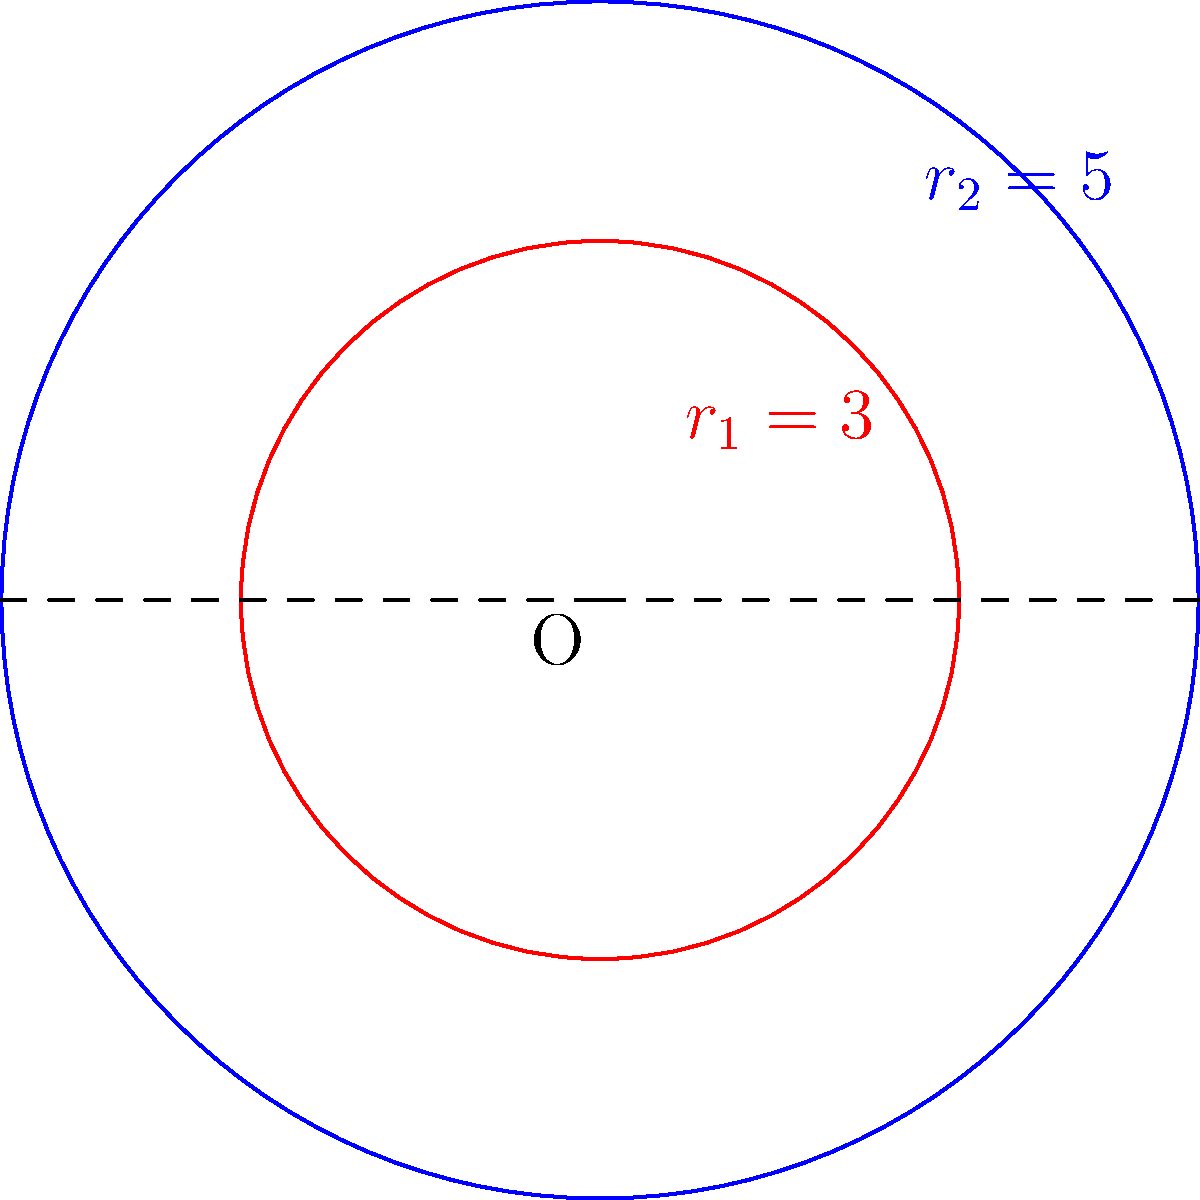In a user acquisition funnel analysis for a freemium game, two concentric circles represent different stages of user engagement. The inner circle (red) has a radius of 3 units, while the outer circle (blue) has a radius of 5 units. Calculate the area of the region between these two circles, which represents users who have progressed beyond initial engagement but haven't yet reached the core gameplay loop. Express your answer in terms of $\pi$ square units. To find the area between two concentric circles, we need to:

1. Calculate the area of the larger circle (outer blue circle)
2. Calculate the area of the smaller circle (inner red circle)
3. Subtract the smaller area from the larger area

Step 1: Area of the larger circle
$A_2 = \pi r_2^2 = \pi (5^2) = 25\pi$

Step 2: Area of the smaller circle
$A_1 = \pi r_1^2 = \pi (3^2) = 9\pi$

Step 3: Area of the region between the circles
$A_{between} = A_2 - A_1 = 25\pi - 9\pi = 16\pi$

Therefore, the area of the region between the two circles, representing users in the intermediate stage of engagement, is $16\pi$ square units.
Answer: $16\pi$ square units 